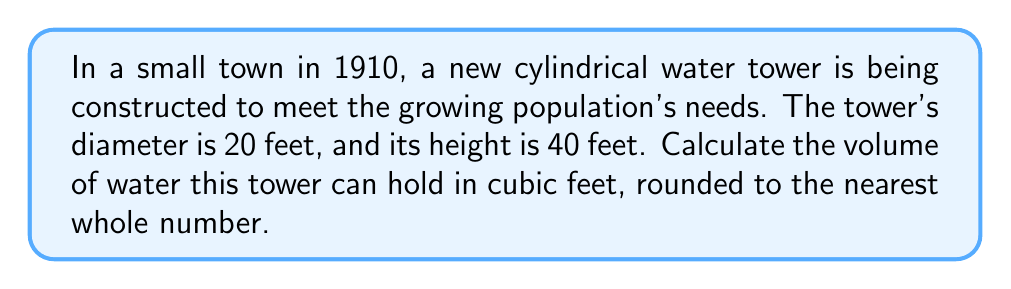Can you answer this question? To solve this problem, we need to use the formula for the volume of a cylinder:

$$V = \pi r^2 h$$

Where:
$V$ = volume
$r$ = radius of the base
$h$ = height of the cylinder

Given:
- Diameter = 20 feet
- Height = 40 feet

Step 1: Calculate the radius
The radius is half the diameter:
$r = \frac{20}{2} = 10$ feet

Step 2: Apply the volume formula
$$V = \pi (10\text{ ft})^2 (40\text{ ft})$$

Step 3: Simplify
$$V = \pi (100\text{ ft}^2) (40\text{ ft})$$
$$V = 4000\pi\text{ ft}^3$$

Step 4: Calculate and round to the nearest whole number
$$V \approx 4000 \times 3.14159 \approx 12566.36\text{ ft}^3$$

Rounding to the nearest whole number:
$$V \approx 12566\text{ ft}^3$$

[asy]
import geometry;

size(200);
real r = 3;
real h = 6;

path base = circle((0,0),r);
path top = circle((0,h),r);

draw(base);
draw(top);
draw((r,0)--(r,h));
draw((-r,0)--(-r,h));

label("r", (r/2,0), E);
label("h", (r,h/2), E);

draw((0,0)--(r,0), arrow=Arrow(TeXHead));
draw((r,0)--(r,h), arrow=Arrow(TeXHead));
[/asy]
Answer: The cylindrical water tower can hold approximately 12,566 cubic feet of water. 